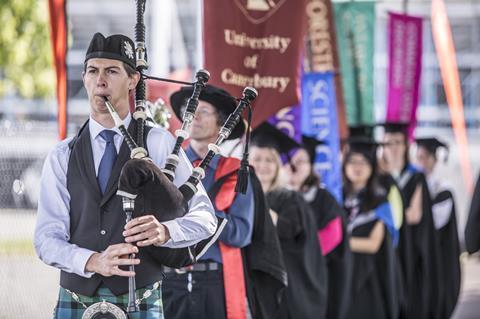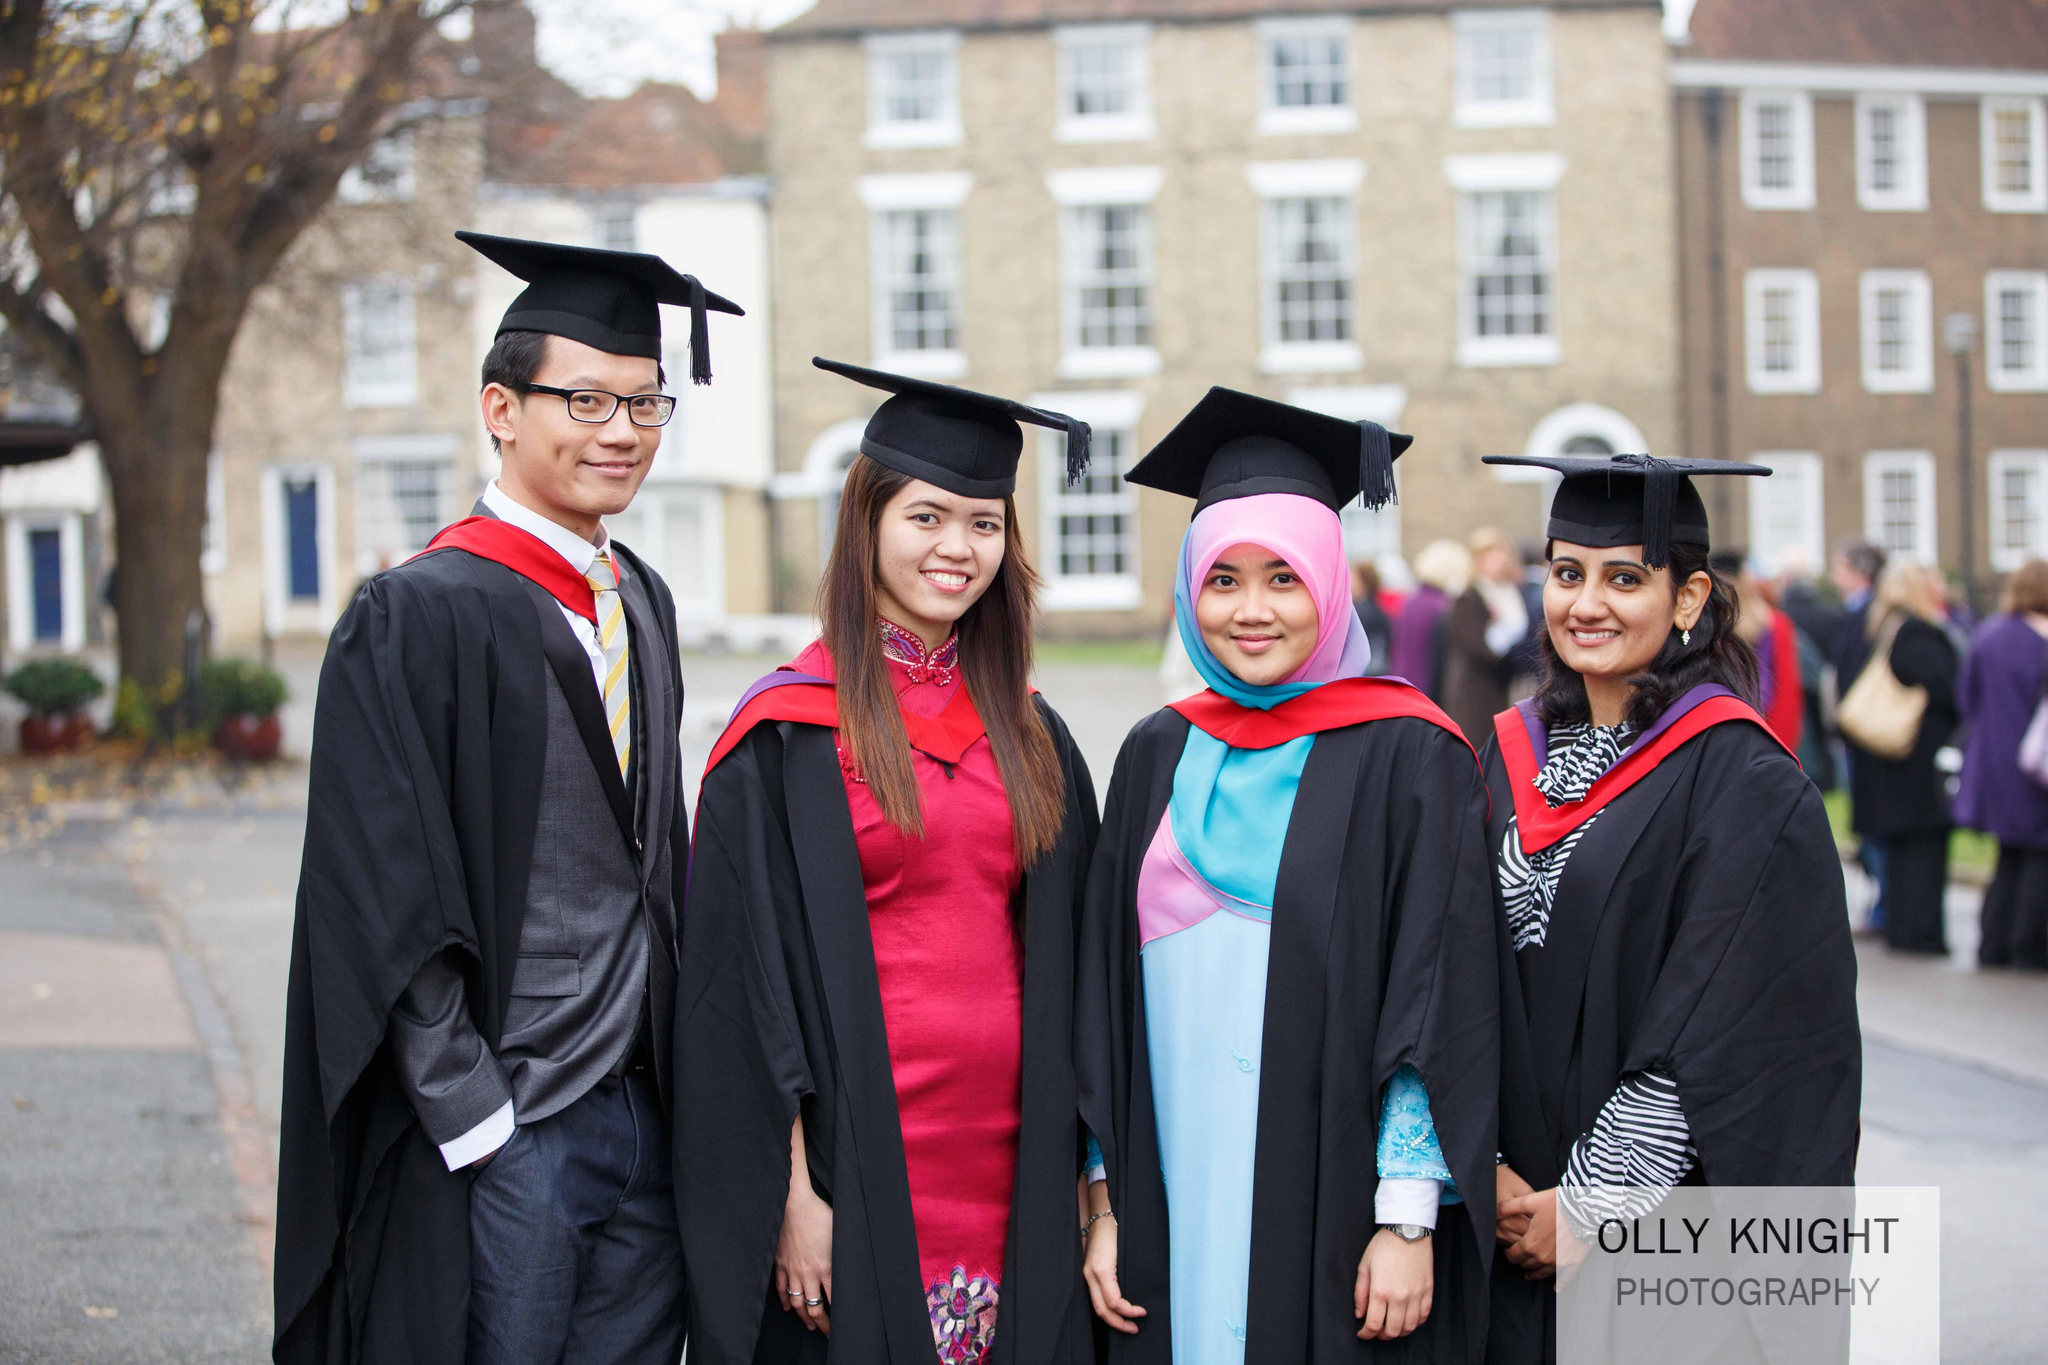The first image is the image on the left, the second image is the image on the right. Evaluate the accuracy of this statement regarding the images: "At least one image includes multiple people wearing red sashes and a non-traditional graduation black cap.". Is it true? Answer yes or no. No. 